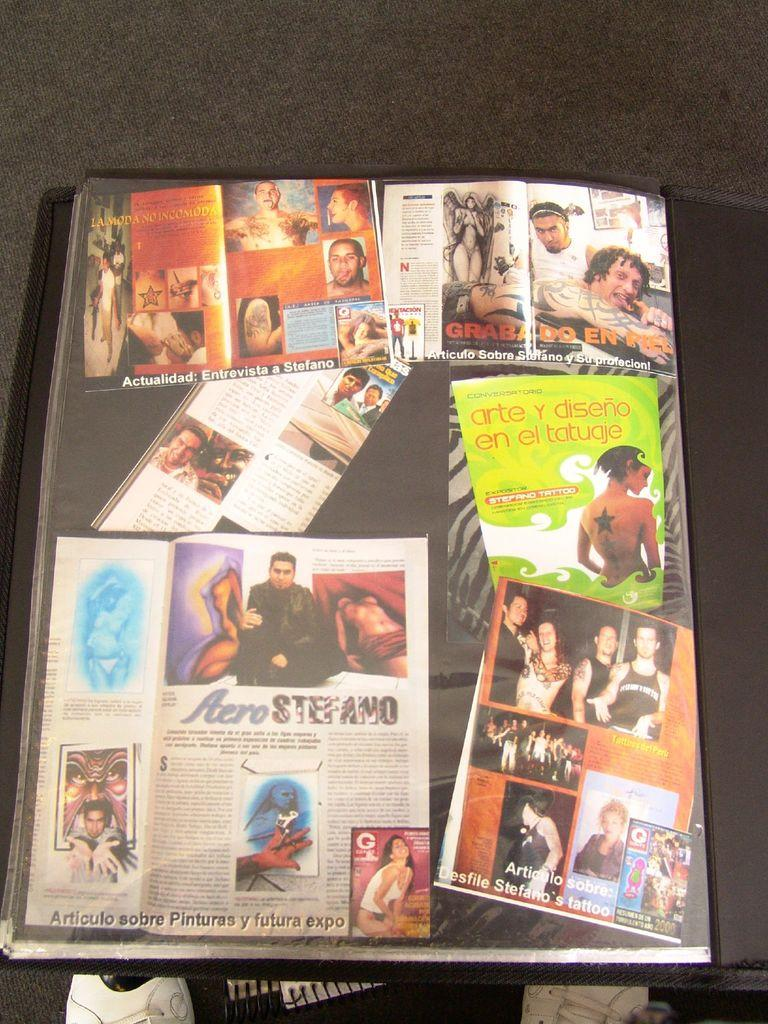<image>
Offer a succinct explanation of the picture presented. The cover of a book shows many magazine articles including one titled Aero Stefano. 